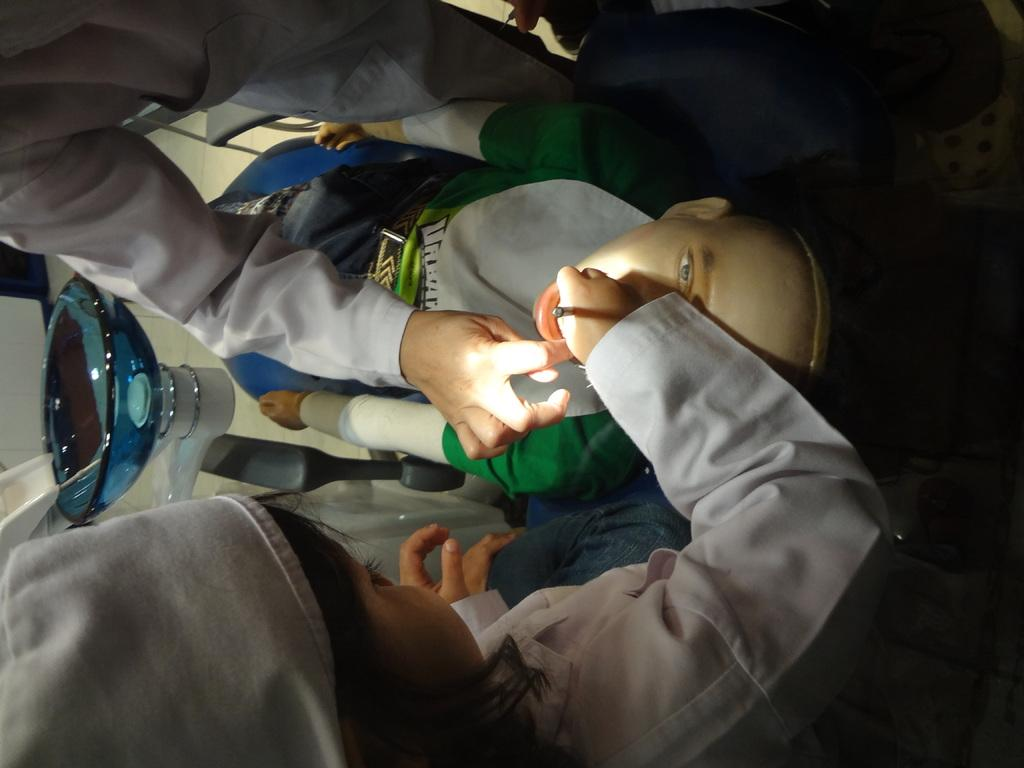How many people are present in the image? There are two people standing in the image. What is the mannequin's position in the image? The mannequin is lying on a chair in the image. What can be seen on the left side of the image? There appears to be a washbasin on the left side of the image. What type of linen is draped over the mannequin in the image? There is no linen draped over the mannequin in the image; it is lying on a chair without any fabric covering it. Can you see a snail crawling on the washbasin in the image? There is no snail present in the image, and therefore no such activity can be observed. 